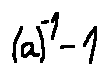Convert formula to latex. <formula><loc_0><loc_0><loc_500><loc_500>( a ) ^ { - 1 } - 1</formula> 